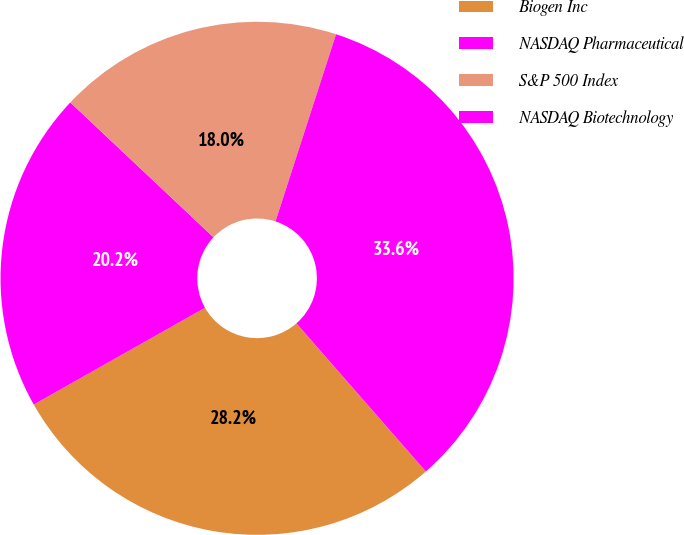Convert chart. <chart><loc_0><loc_0><loc_500><loc_500><pie_chart><fcel>Biogen Inc<fcel>NASDAQ Pharmaceutical<fcel>S&P 500 Index<fcel>NASDAQ Biotechnology<nl><fcel>28.24%<fcel>20.21%<fcel>17.96%<fcel>33.59%<nl></chart> 